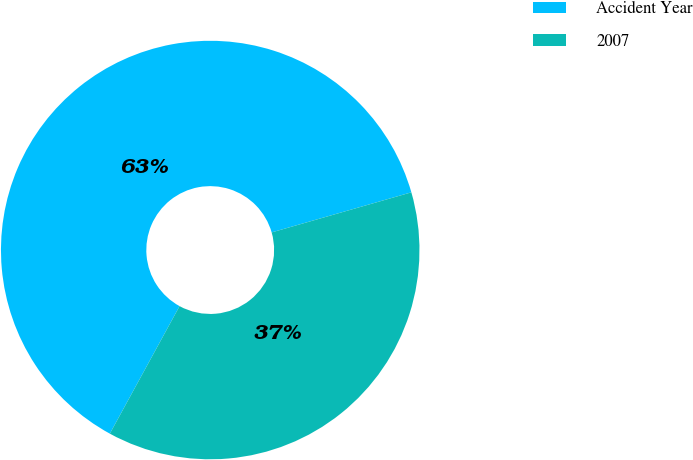<chart> <loc_0><loc_0><loc_500><loc_500><pie_chart><fcel>Accident Year<fcel>2007<nl><fcel>62.59%<fcel>37.41%<nl></chart> 